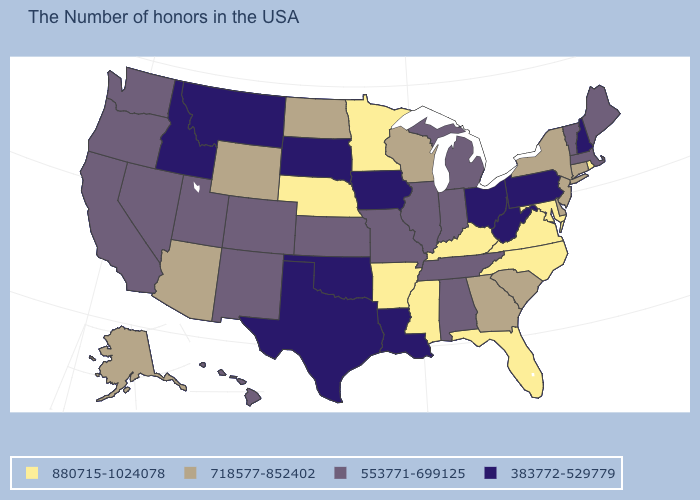What is the highest value in the West ?
Be succinct. 718577-852402. What is the value of Delaware?
Write a very short answer. 718577-852402. What is the value of Maine?
Answer briefly. 553771-699125. Among the states that border Texas , which have the highest value?
Short answer required. Arkansas. Name the states that have a value in the range 718577-852402?
Answer briefly. Connecticut, New York, New Jersey, Delaware, South Carolina, Georgia, Wisconsin, North Dakota, Wyoming, Arizona, Alaska. What is the value of Ohio?
Write a very short answer. 383772-529779. What is the lowest value in the Northeast?
Short answer required. 383772-529779. What is the lowest value in the USA?
Give a very brief answer. 383772-529779. Does the first symbol in the legend represent the smallest category?
Write a very short answer. No. What is the value of Nebraska?
Be succinct. 880715-1024078. Which states have the highest value in the USA?
Answer briefly. Rhode Island, Maryland, Virginia, North Carolina, Florida, Kentucky, Mississippi, Arkansas, Minnesota, Nebraska. Name the states that have a value in the range 383772-529779?
Concise answer only. New Hampshire, Pennsylvania, West Virginia, Ohio, Louisiana, Iowa, Oklahoma, Texas, South Dakota, Montana, Idaho. What is the lowest value in states that border Oklahoma?
Keep it brief. 383772-529779. What is the lowest value in states that border North Dakota?
Concise answer only. 383772-529779. What is the lowest value in the Northeast?
Short answer required. 383772-529779. 